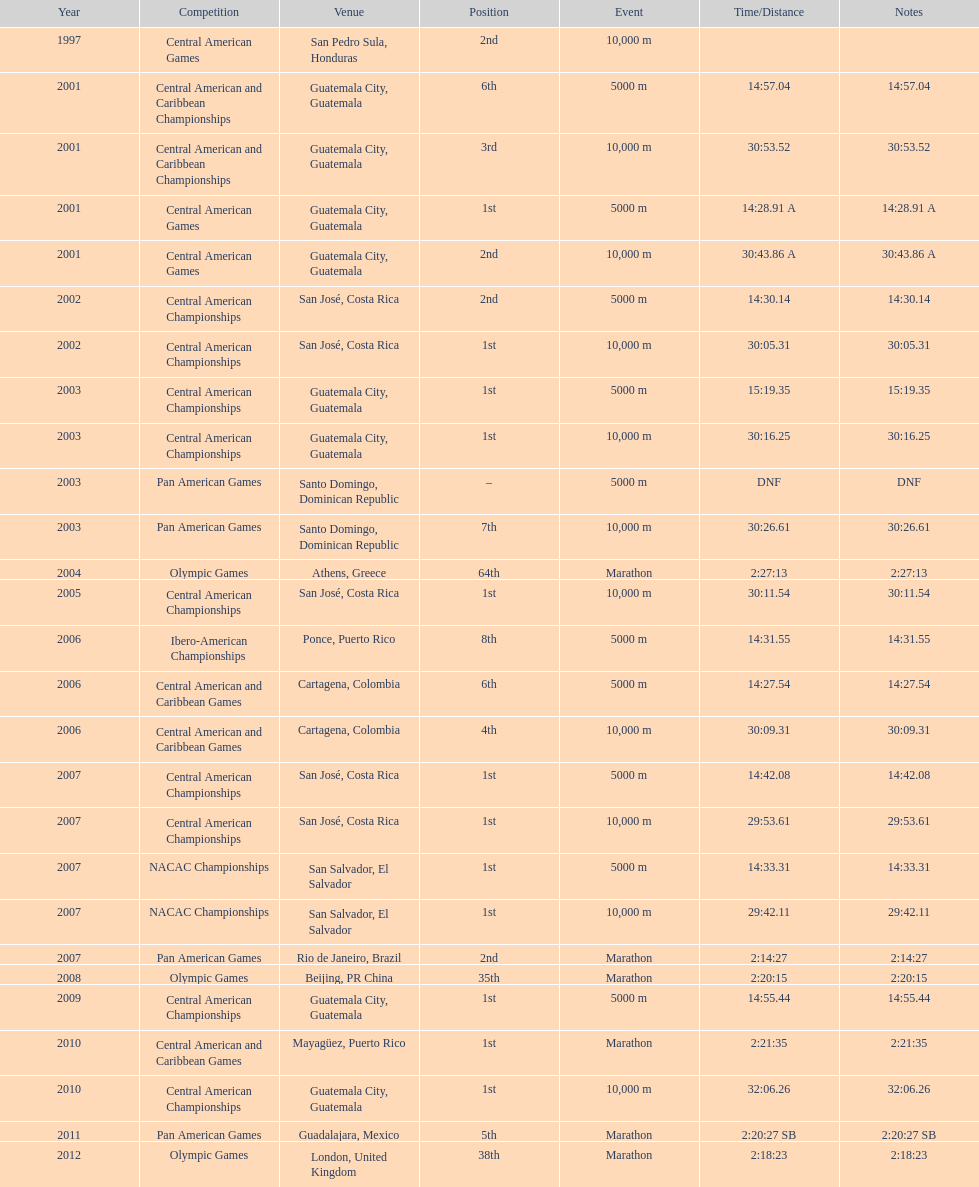How many times has the position of 1st been achieved? 12. 